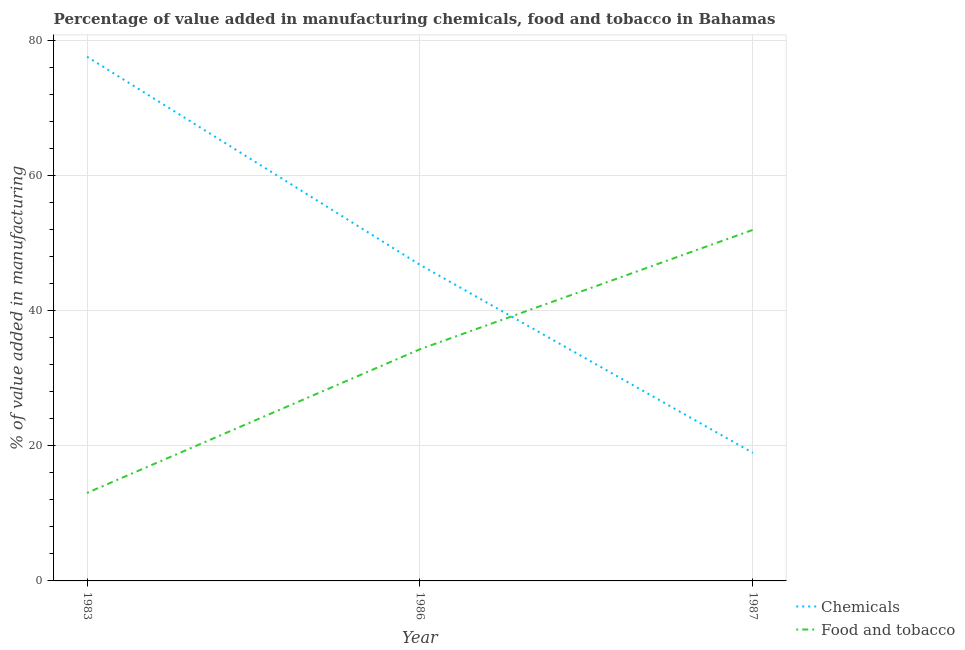Does the line corresponding to value added by manufacturing food and tobacco intersect with the line corresponding to value added by  manufacturing chemicals?
Your response must be concise. Yes. What is the value added by  manufacturing chemicals in 1987?
Offer a very short reply. 18.93. Across all years, what is the maximum value added by  manufacturing chemicals?
Your response must be concise. 77.54. Across all years, what is the minimum value added by manufacturing food and tobacco?
Your answer should be compact. 13.02. In which year was the value added by  manufacturing chemicals maximum?
Your answer should be compact. 1983. What is the total value added by manufacturing food and tobacco in the graph?
Provide a succinct answer. 99.21. What is the difference between the value added by  manufacturing chemicals in 1983 and that in 1987?
Ensure brevity in your answer.  58.6. What is the difference between the value added by  manufacturing chemicals in 1987 and the value added by manufacturing food and tobacco in 1983?
Give a very brief answer. 5.92. What is the average value added by manufacturing food and tobacco per year?
Give a very brief answer. 33.07. In the year 1983, what is the difference between the value added by manufacturing food and tobacco and value added by  manufacturing chemicals?
Keep it short and to the point. -64.52. In how many years, is the value added by  manufacturing chemicals greater than 52 %?
Your answer should be compact. 1. What is the ratio of the value added by  manufacturing chemicals in 1983 to that in 1986?
Ensure brevity in your answer.  1.66. What is the difference between the highest and the second highest value added by  manufacturing chemicals?
Ensure brevity in your answer.  30.78. What is the difference between the highest and the lowest value added by manufacturing food and tobacco?
Offer a very short reply. 38.91. In how many years, is the value added by  manufacturing chemicals greater than the average value added by  manufacturing chemicals taken over all years?
Give a very brief answer. 1. Is the sum of the value added by  manufacturing chemicals in 1986 and 1987 greater than the maximum value added by manufacturing food and tobacco across all years?
Provide a short and direct response. Yes. Does the value added by manufacturing food and tobacco monotonically increase over the years?
Offer a very short reply. Yes. Is the value added by manufacturing food and tobacco strictly less than the value added by  manufacturing chemicals over the years?
Keep it short and to the point. No. How many lines are there?
Your response must be concise. 2. How many years are there in the graph?
Keep it short and to the point. 3. What is the difference between two consecutive major ticks on the Y-axis?
Offer a very short reply. 20. Are the values on the major ticks of Y-axis written in scientific E-notation?
Your answer should be compact. No. Does the graph contain grids?
Make the answer very short. Yes. Where does the legend appear in the graph?
Offer a very short reply. Bottom right. How many legend labels are there?
Your response must be concise. 2. How are the legend labels stacked?
Ensure brevity in your answer.  Vertical. What is the title of the graph?
Offer a very short reply. Percentage of value added in manufacturing chemicals, food and tobacco in Bahamas. What is the label or title of the Y-axis?
Give a very brief answer. % of value added in manufacturing. What is the % of value added in manufacturing in Chemicals in 1983?
Ensure brevity in your answer.  77.54. What is the % of value added in manufacturing in Food and tobacco in 1983?
Offer a terse response. 13.02. What is the % of value added in manufacturing of Chemicals in 1986?
Provide a succinct answer. 46.76. What is the % of value added in manufacturing in Food and tobacco in 1986?
Give a very brief answer. 34.27. What is the % of value added in manufacturing in Chemicals in 1987?
Offer a very short reply. 18.93. What is the % of value added in manufacturing of Food and tobacco in 1987?
Offer a very short reply. 51.93. Across all years, what is the maximum % of value added in manufacturing in Chemicals?
Make the answer very short. 77.54. Across all years, what is the maximum % of value added in manufacturing of Food and tobacco?
Your answer should be compact. 51.93. Across all years, what is the minimum % of value added in manufacturing in Chemicals?
Offer a terse response. 18.93. Across all years, what is the minimum % of value added in manufacturing in Food and tobacco?
Ensure brevity in your answer.  13.02. What is the total % of value added in manufacturing of Chemicals in the graph?
Provide a succinct answer. 143.23. What is the total % of value added in manufacturing of Food and tobacco in the graph?
Your answer should be compact. 99.21. What is the difference between the % of value added in manufacturing of Chemicals in 1983 and that in 1986?
Your answer should be very brief. 30.78. What is the difference between the % of value added in manufacturing of Food and tobacco in 1983 and that in 1986?
Ensure brevity in your answer.  -21.25. What is the difference between the % of value added in manufacturing of Chemicals in 1983 and that in 1987?
Make the answer very short. 58.6. What is the difference between the % of value added in manufacturing in Food and tobacco in 1983 and that in 1987?
Offer a terse response. -38.91. What is the difference between the % of value added in manufacturing of Chemicals in 1986 and that in 1987?
Your answer should be compact. 27.82. What is the difference between the % of value added in manufacturing in Food and tobacco in 1986 and that in 1987?
Your response must be concise. -17.66. What is the difference between the % of value added in manufacturing in Chemicals in 1983 and the % of value added in manufacturing in Food and tobacco in 1986?
Your response must be concise. 43.27. What is the difference between the % of value added in manufacturing in Chemicals in 1983 and the % of value added in manufacturing in Food and tobacco in 1987?
Offer a terse response. 25.61. What is the difference between the % of value added in manufacturing of Chemicals in 1986 and the % of value added in manufacturing of Food and tobacco in 1987?
Your answer should be compact. -5.17. What is the average % of value added in manufacturing of Chemicals per year?
Your response must be concise. 47.74. What is the average % of value added in manufacturing in Food and tobacco per year?
Keep it short and to the point. 33.07. In the year 1983, what is the difference between the % of value added in manufacturing of Chemicals and % of value added in manufacturing of Food and tobacco?
Offer a very short reply. 64.52. In the year 1986, what is the difference between the % of value added in manufacturing of Chemicals and % of value added in manufacturing of Food and tobacco?
Ensure brevity in your answer.  12.49. In the year 1987, what is the difference between the % of value added in manufacturing of Chemicals and % of value added in manufacturing of Food and tobacco?
Your answer should be compact. -32.99. What is the ratio of the % of value added in manufacturing in Chemicals in 1983 to that in 1986?
Offer a terse response. 1.66. What is the ratio of the % of value added in manufacturing in Food and tobacco in 1983 to that in 1986?
Ensure brevity in your answer.  0.38. What is the ratio of the % of value added in manufacturing in Chemicals in 1983 to that in 1987?
Offer a very short reply. 4.09. What is the ratio of the % of value added in manufacturing in Food and tobacco in 1983 to that in 1987?
Provide a succinct answer. 0.25. What is the ratio of the % of value added in manufacturing of Chemicals in 1986 to that in 1987?
Your response must be concise. 2.47. What is the ratio of the % of value added in manufacturing in Food and tobacco in 1986 to that in 1987?
Keep it short and to the point. 0.66. What is the difference between the highest and the second highest % of value added in manufacturing in Chemicals?
Provide a succinct answer. 30.78. What is the difference between the highest and the second highest % of value added in manufacturing of Food and tobacco?
Offer a very short reply. 17.66. What is the difference between the highest and the lowest % of value added in manufacturing in Chemicals?
Offer a very short reply. 58.6. What is the difference between the highest and the lowest % of value added in manufacturing in Food and tobacco?
Your response must be concise. 38.91. 